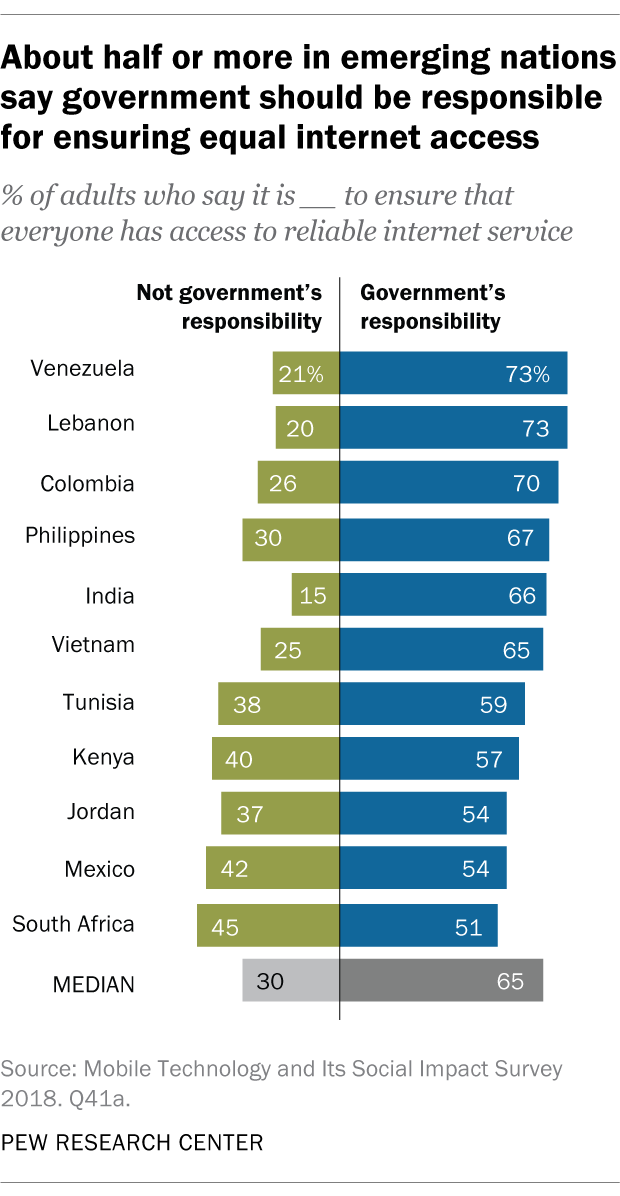Indicate a few pertinent items in this graphic. The ratio of the medians of the green and blue bars is 0.259027778... The median of green bars is 30. 